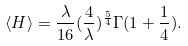Convert formula to latex. <formula><loc_0><loc_0><loc_500><loc_500>\langle H \rangle = \frac { \lambda } { 1 6 } ( \frac { 4 } { \lambda } ) ^ { \frac { 5 } { 4 } } \Gamma ( 1 + \frac { 1 } { 4 } ) .</formula> 